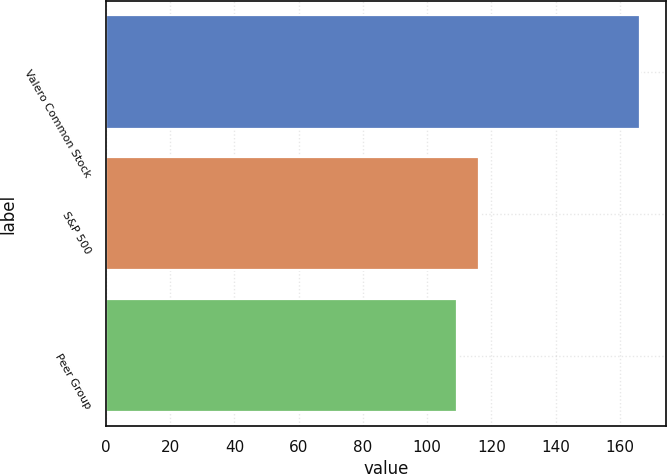Convert chart to OTSL. <chart><loc_0><loc_0><loc_500><loc_500><bar_chart><fcel>Valero Common Stock<fcel>S&P 500<fcel>Peer Group<nl><fcel>166.17<fcel>116<fcel>109.23<nl></chart> 